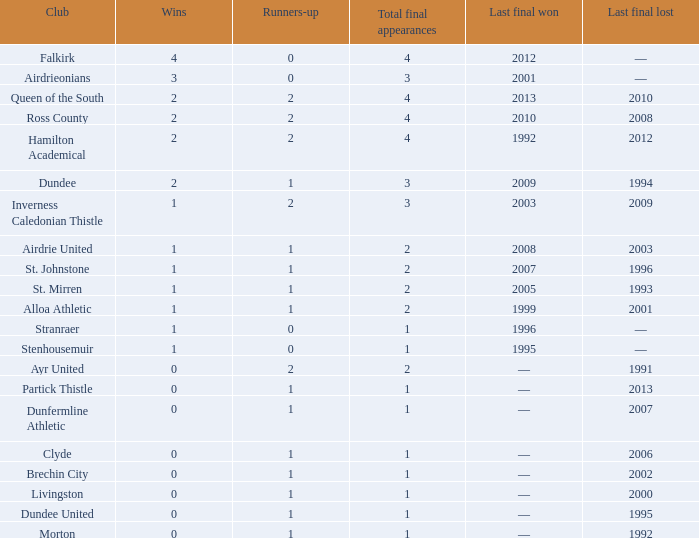How manywins for dunfermline athletic that has a total final appearances less than 2? 0.0. 